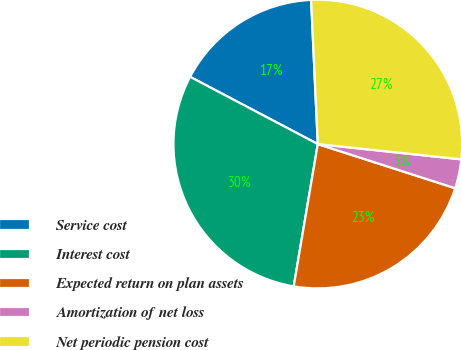Convert chart to OTSL. <chart><loc_0><loc_0><loc_500><loc_500><pie_chart><fcel>Service cost<fcel>Interest cost<fcel>Expected return on plan assets<fcel>Amortization of net loss<fcel>Net periodic pension cost<nl><fcel>16.55%<fcel>30.05%<fcel>22.72%<fcel>3.26%<fcel>27.43%<nl></chart> 